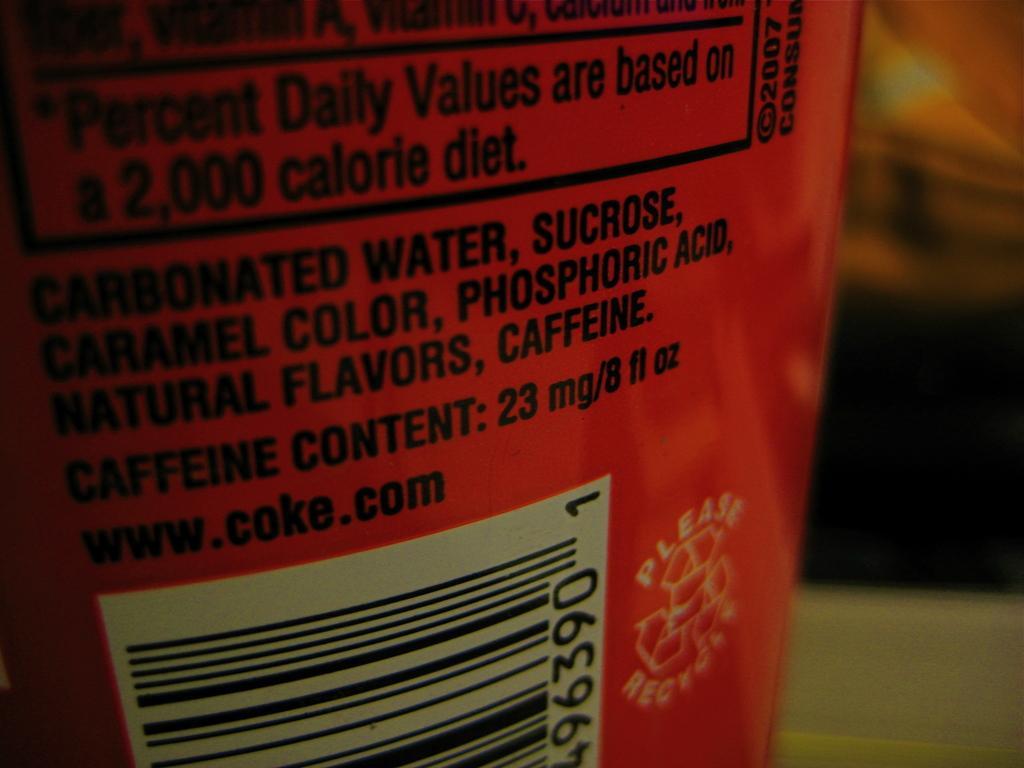Could you give a brief overview of what you see in this image? In the center of the image we can see a tin. 